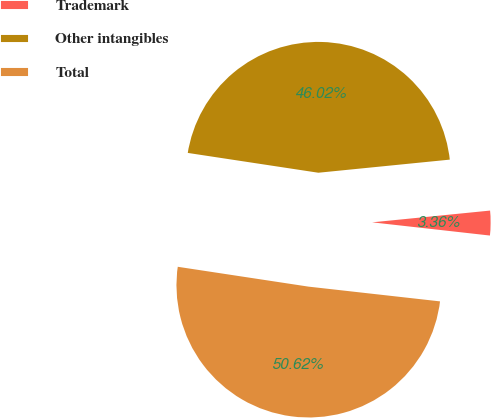<chart> <loc_0><loc_0><loc_500><loc_500><pie_chart><fcel>Trademark<fcel>Other intangibles<fcel>Total<nl><fcel>3.36%<fcel>46.02%<fcel>50.62%<nl></chart> 